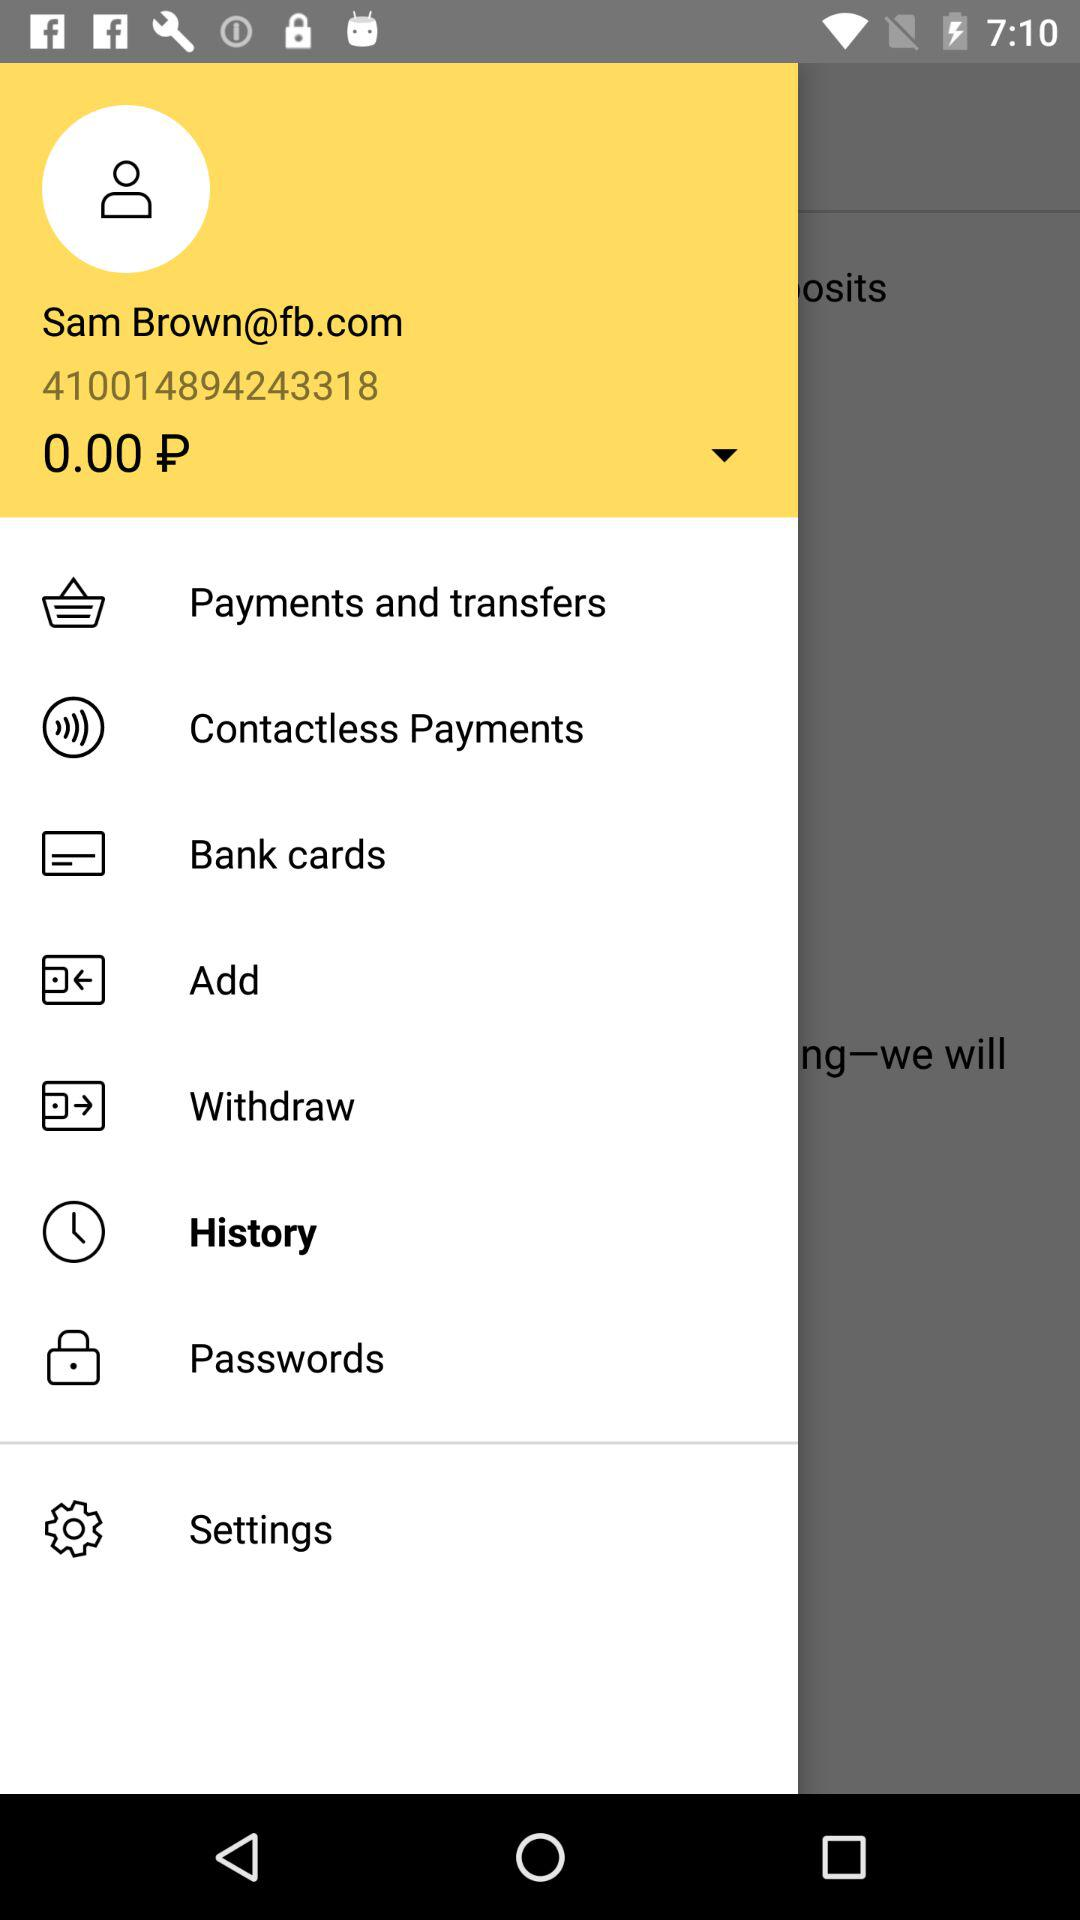What is the email address? The email address is Sam Brown@fb.com. 